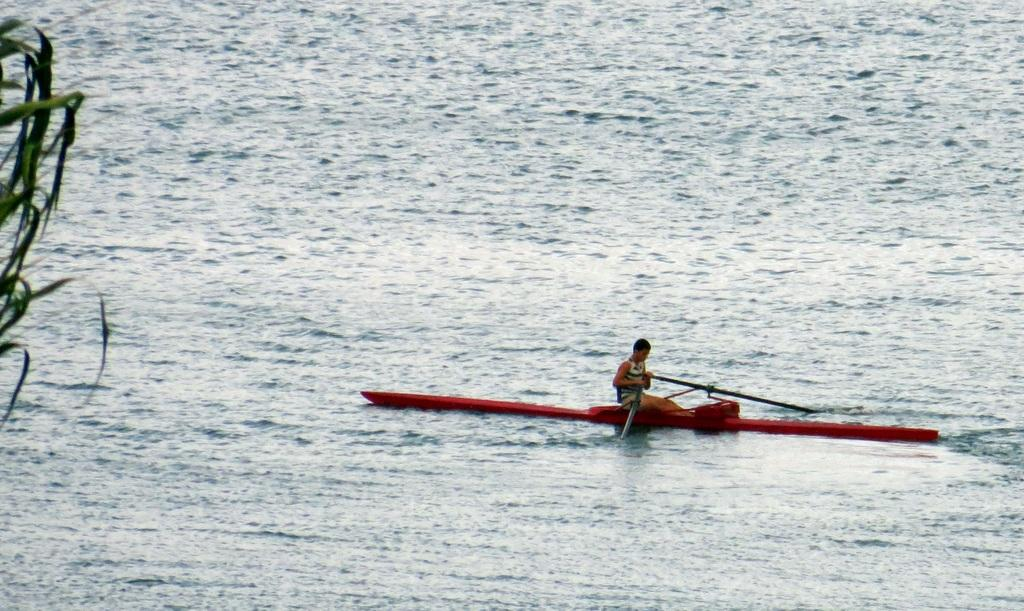What is the person in the image doing? There is a person riding a boat in the image. Where is the boat located? The boat is on the water. What can be seen on the left side of the image? There is a tree on the left side of the image. What type of flowers are growing on the boat in the image? There are no flowers present on the boat in the image. 